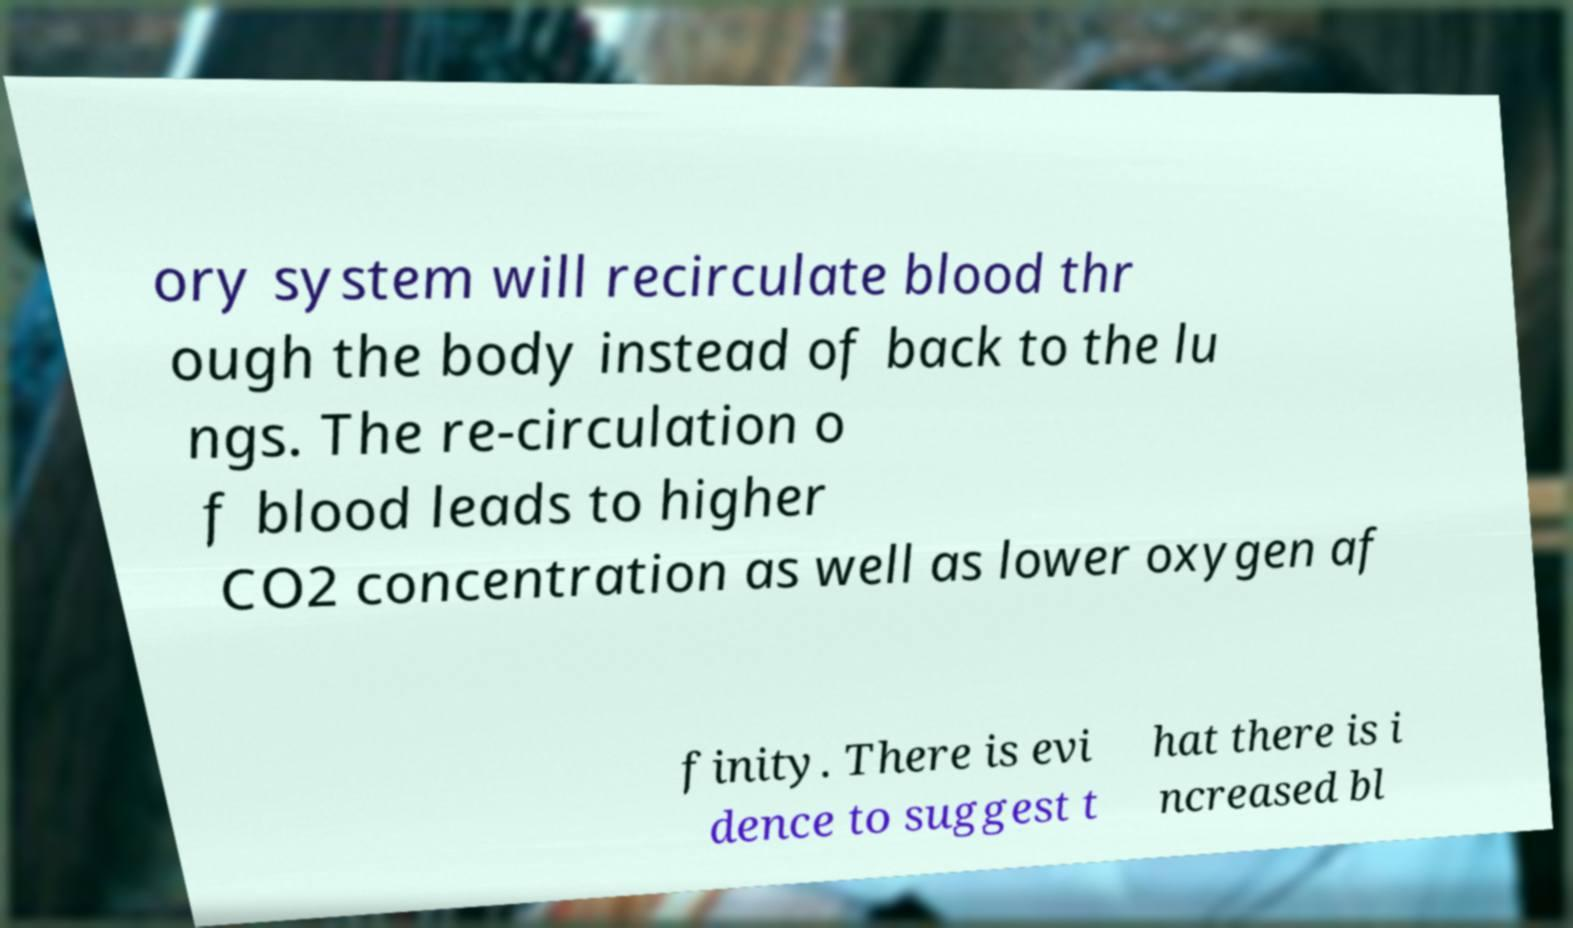Could you assist in decoding the text presented in this image and type it out clearly? ory system will recirculate blood thr ough the body instead of back to the lu ngs. The re-circulation o f blood leads to higher CO2 concentration as well as lower oxygen af finity. There is evi dence to suggest t hat there is i ncreased bl 